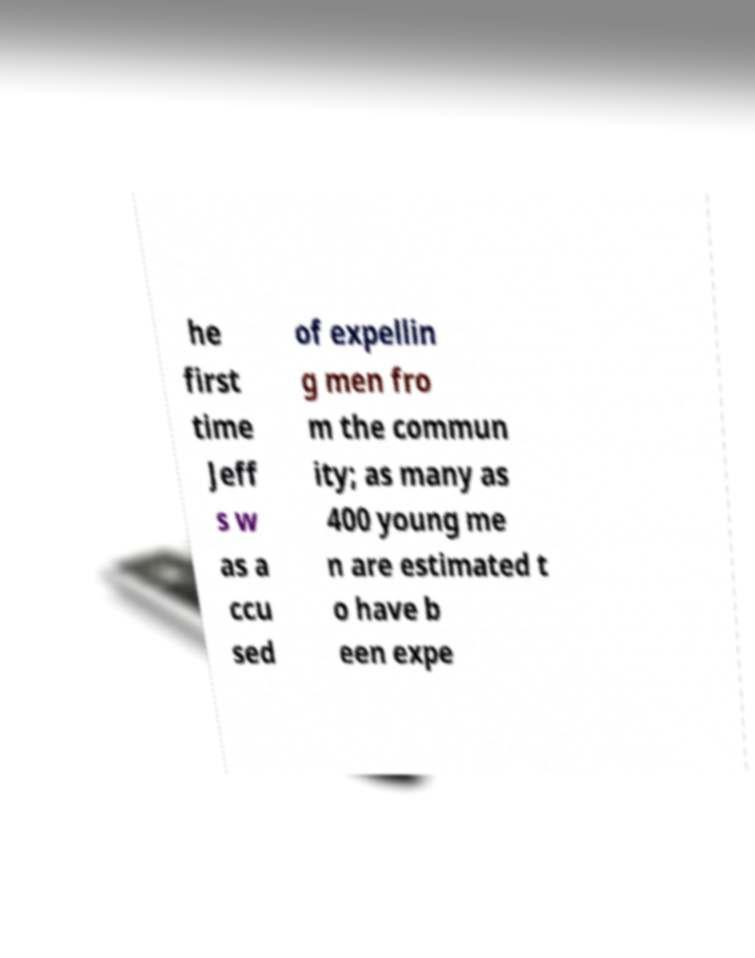I need the written content from this picture converted into text. Can you do that? he first time Jeff s w as a ccu sed of expellin g men fro m the commun ity; as many as 400 young me n are estimated t o have b een expe 